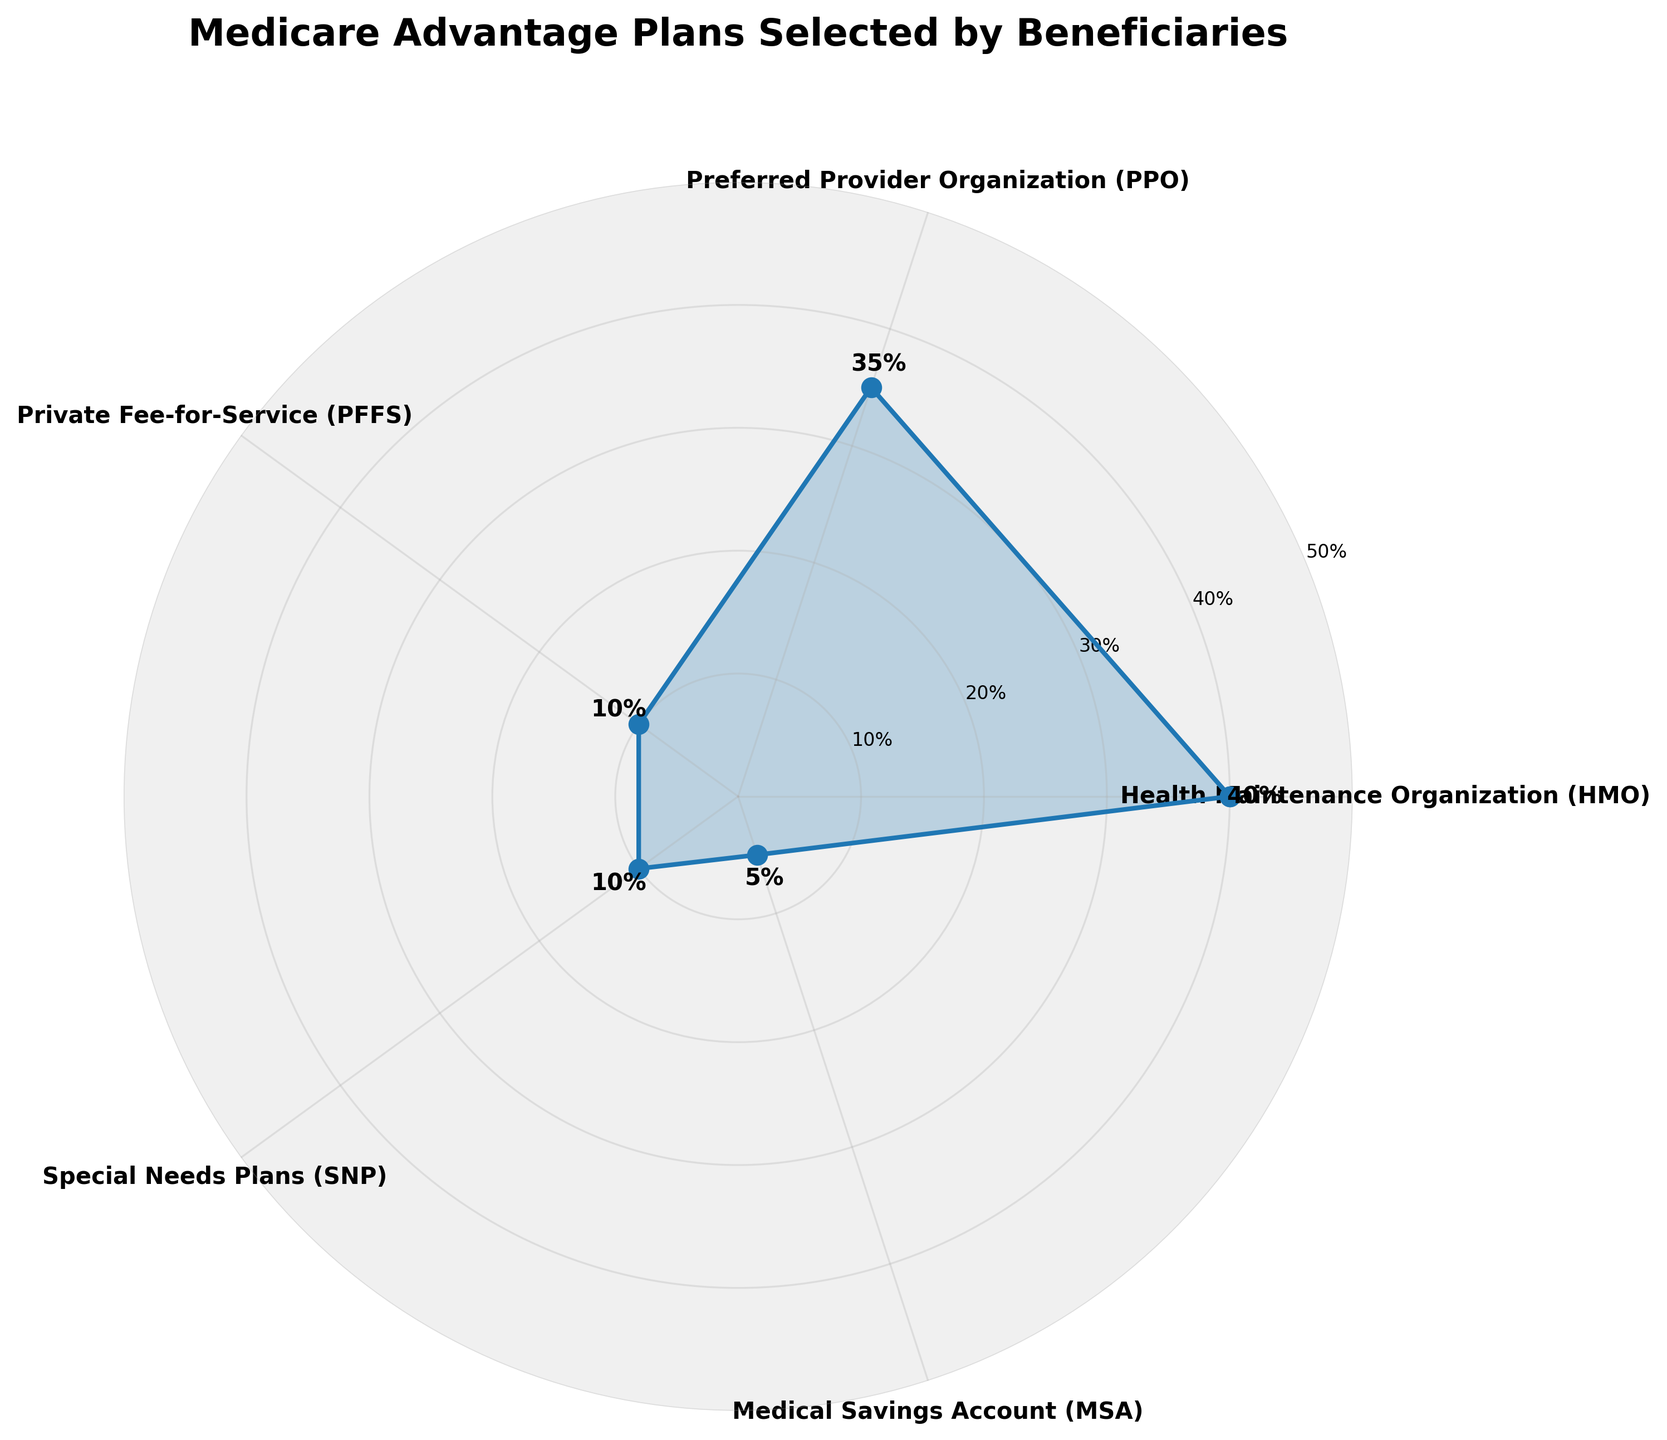What's the title of the chart? The title of the chart is written at the top and explains what the data represents. It reads "Medicare Advantage Plans Selected by Beneficiaries".
Answer: Medicare Advantage Plans Selected by Beneficiaries What is the percentage for Health Maintenance Organization (HMO) plans? On the chart, Health Maintenance Organization (HMO) plans are represented in the polar area, and their label reads 40%.
Answer: 40% How do the percentages for Preferred Provider Organization (PPO) and Special Needs Plans (SNP) compare? By observing the chart, Preferred Provider Organization (PPO) has a percentage of 35%, while Special Needs Plans (SNP) have a percentage of 10%. The PPO percentage is larger than the SNP percentage.
Answer: PPO is larger What is the sum of the percentages for Private Fee-for-Service (PFFS) and Medical Savings Account (MSA) plans? Private Fee-for-Service (PFFS) is at 10%, and Medical Savings Account (MSA) is at 5%, so summing them up: 10% + 5% = 15%.
Answer: 15% Which plan type has the smallest percentage of beneficiaries? The smallest percentage is indicated by the shortest length from the center in the polar chart. Medical Savings Account (MSA) plans have the smallest percentage at 5%.
Answer: Medical Savings Account (MSA) What is the range of percentages shown in the chart? The range is determined by subtracting the smallest percentage from the largest percentage. The highest is Health Maintenance Organization (HMO) at 40%, and the lowest is Medical Savings Account (MSA) at 5%. So, the range is 40% - 5% = 35%.
Answer: 35% How many types of Medicare Advantage Plans are represented in the chart? The chart labels indicate five distinct types of Medicare Advantage Plans.
Answer: Five If you were to divide the plans into two groups, with one group containing the three highest percentages and the other the two lowest, what would the total percentage be for each group? The three highest percentages are HMO (40%), PPO (35%), and PFFS (10%). Their sum is 40% + 35% + 10% = 85%. The two lowest are SNP (10%) and MSA (5%). Their sum is 10% + 5% = 15%. So the totals for the two groups would be 85% and 15%.
Answer: 85% and 15% What can you infer about popular and less popular Medicare Advantage plans based on the chart? Plans with higher percentages like HMO (40%) and PPO (35%) are more popular among beneficiaries, whereas MSA (5%) and PFFS (10%) have fewer selections, indicating they are less popular.
Answer: HMO and PPO are more popular, MSA and PFFS are less popular 